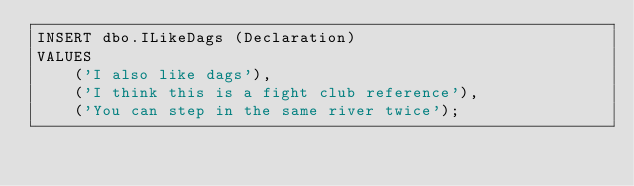Convert code to text. <code><loc_0><loc_0><loc_500><loc_500><_SQL_>INSERT dbo.ILikeDags (Declaration)
VALUES 
    ('I also like dags'),
    ('I think this is a fight club reference'),
    ('You can step in the same river twice');

</code> 